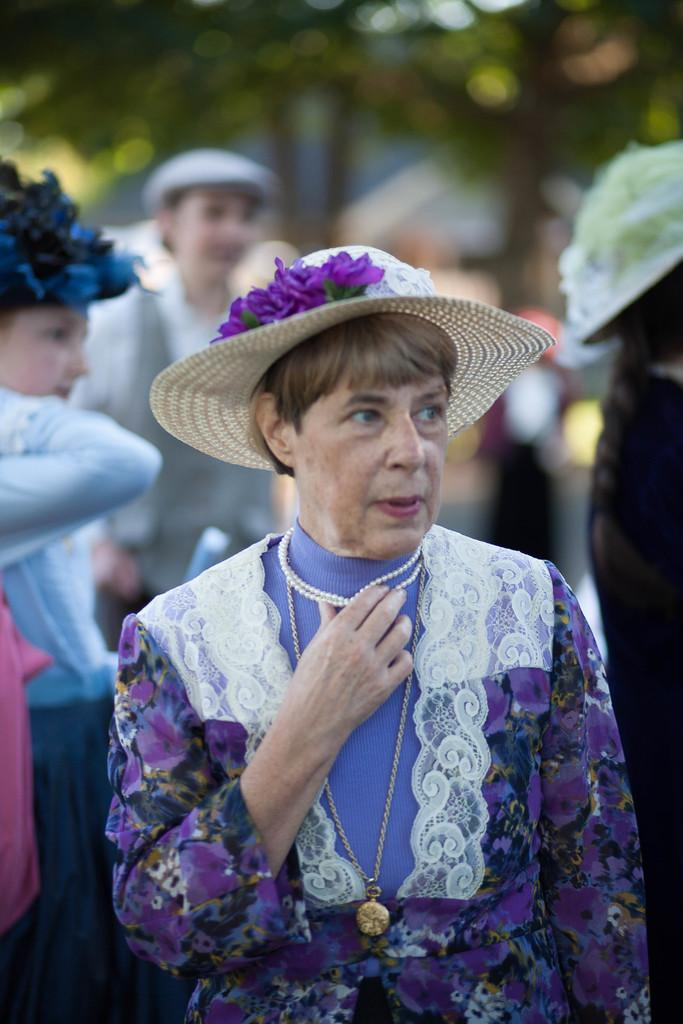Who is the main subject in the image? There is a woman in the image. What is the woman doing in the image? The woman is standing. What is the woman wearing in the image? The woman is wearing clothes and a hat. Are there any other people in the image? Yes, there are other people in the image. What else can be seen in the image? There is a tree in the image. What type of polish is the woman applying to her nails in the image? There is no indication in the image that the woman is applying polish to her nails, as she is wearing a hat and not shown with her hands. 